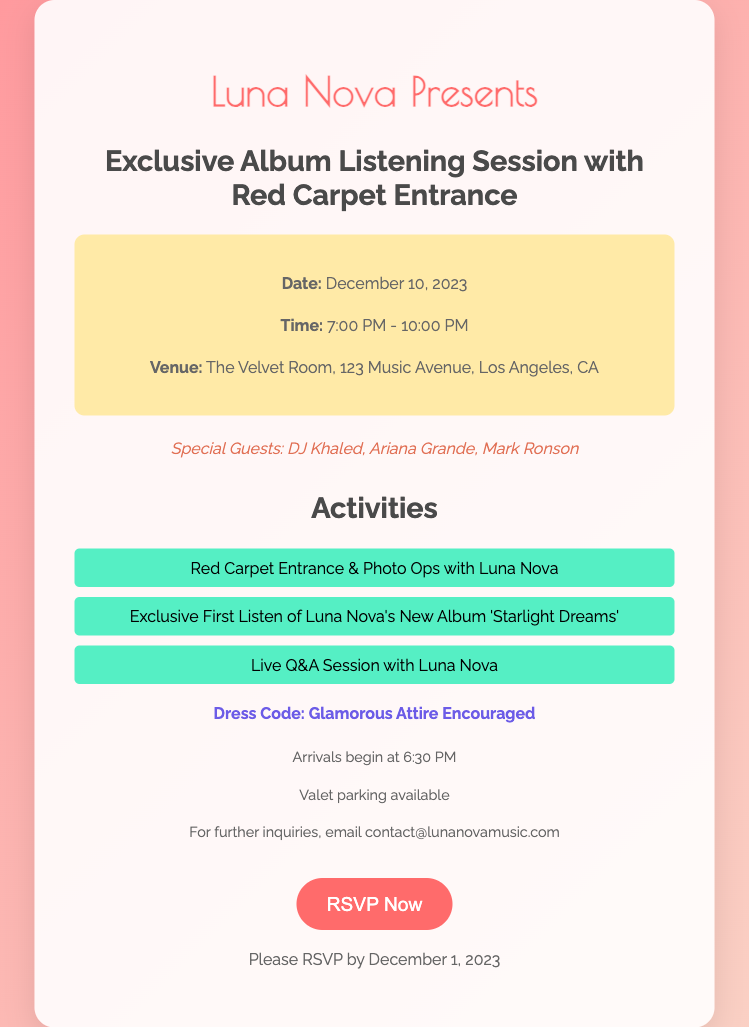what is the date of the event? The date of the event is explicitly mentioned in the document under event details.
Answer: December 10, 2023 what is the venue name? The venue name is provided within the event details section of the document.
Answer: The Velvet Room what time does the event start? The start time is specified in the document under event details.
Answer: 7:00 PM who are the special guests? The special guests are listed in the document, giving specific names.
Answer: DJ Khaled, Ariana Grande, Mark Ronson what activities are included at the event? The activities are enumerated in the activities section, which can be directly referenced.
Answer: Red Carpet Entrance & Photo Ops with Luna Nova, Exclusive First Listen of Luna Nova's New Album 'Starlight Dreams', Live Q&A Session with Luna Nova what is the dress code? The dress code is clearly stated in the document under the corresponding section.
Answer: Glamorous Attire Encouraged what is the RSVP deadline? The RSVP deadline is mentioned at the bottom of the card.
Answer: December 1, 2023 when do arrivals begin? The time for arrivals is mentioned in the additional information section.
Answer: 6:30 PM is valet parking available? The availability of valet parking is specified in the additional information.
Answer: Yes 